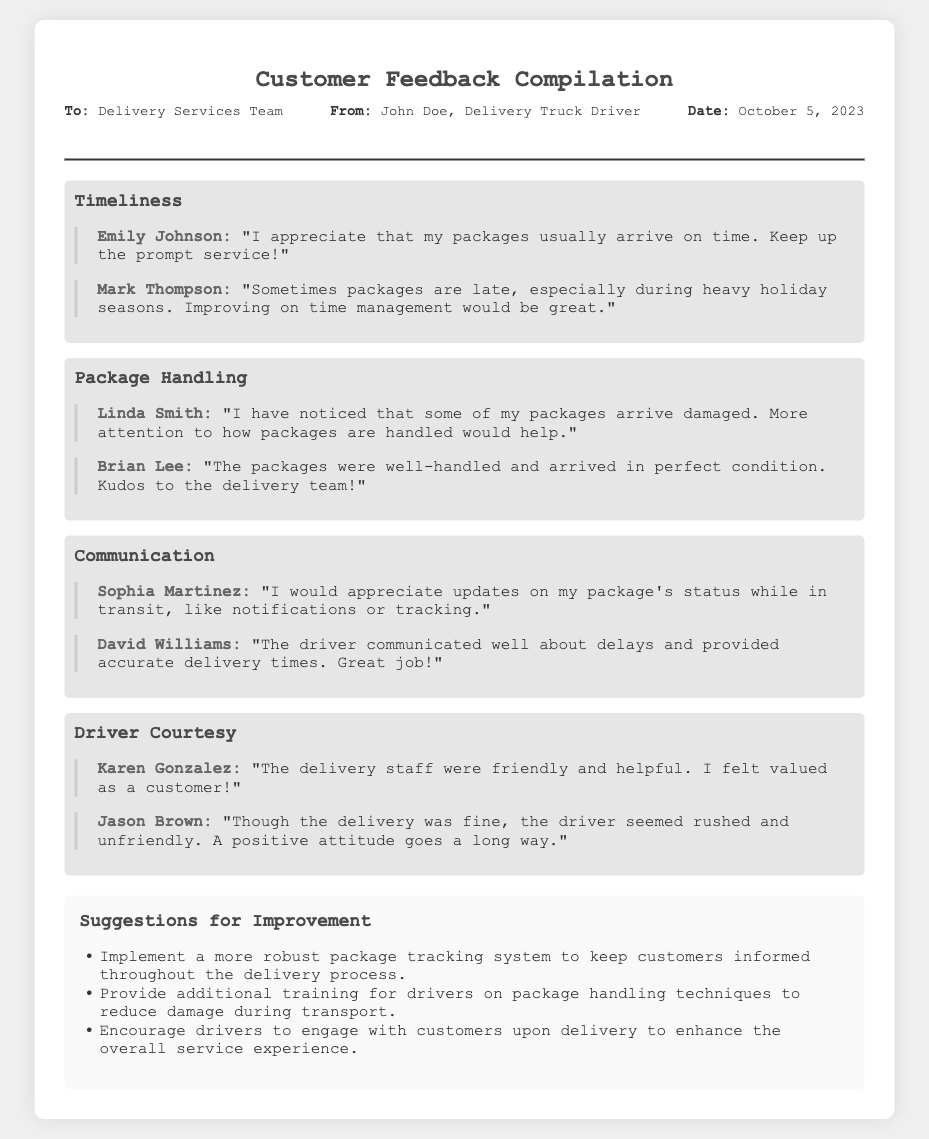what is the date of the memo? The date of the memo is listed in the header section, which is October 5, 2023.
Answer: October 5, 2023 who sent the memo? The memo is sent from John Doe, who is identified as a Delivery Truck Driver.
Answer: John Doe what theme addresses package condition upon arrival? The theme related to package condition upon arrival is "Package Handling."
Answer: Package Handling how many customers provided feedback regarding driver courtesy? There are two feedback entries under the theme "Driver Courtesy."
Answer: Two what suggestion is made regarding package tracking? A suggestion is made to implement a more robust package tracking system.
Answer: Implement a more robust package tracking system which customer appreciated timely deliveries? The customer who appreciated timely deliveries is Emily Johnson.
Answer: Emily Johnson what is the focus of the "Communication" theme? The focus of the "Communication" theme is on updates and information about the package during transit.
Answer: Updates and information about the package during transit what did David Williams praise in his feedback? David Williams praised the driver's communication about delays and accurate delivery times.
Answer: Driver's communication about delays and accurate delivery times 